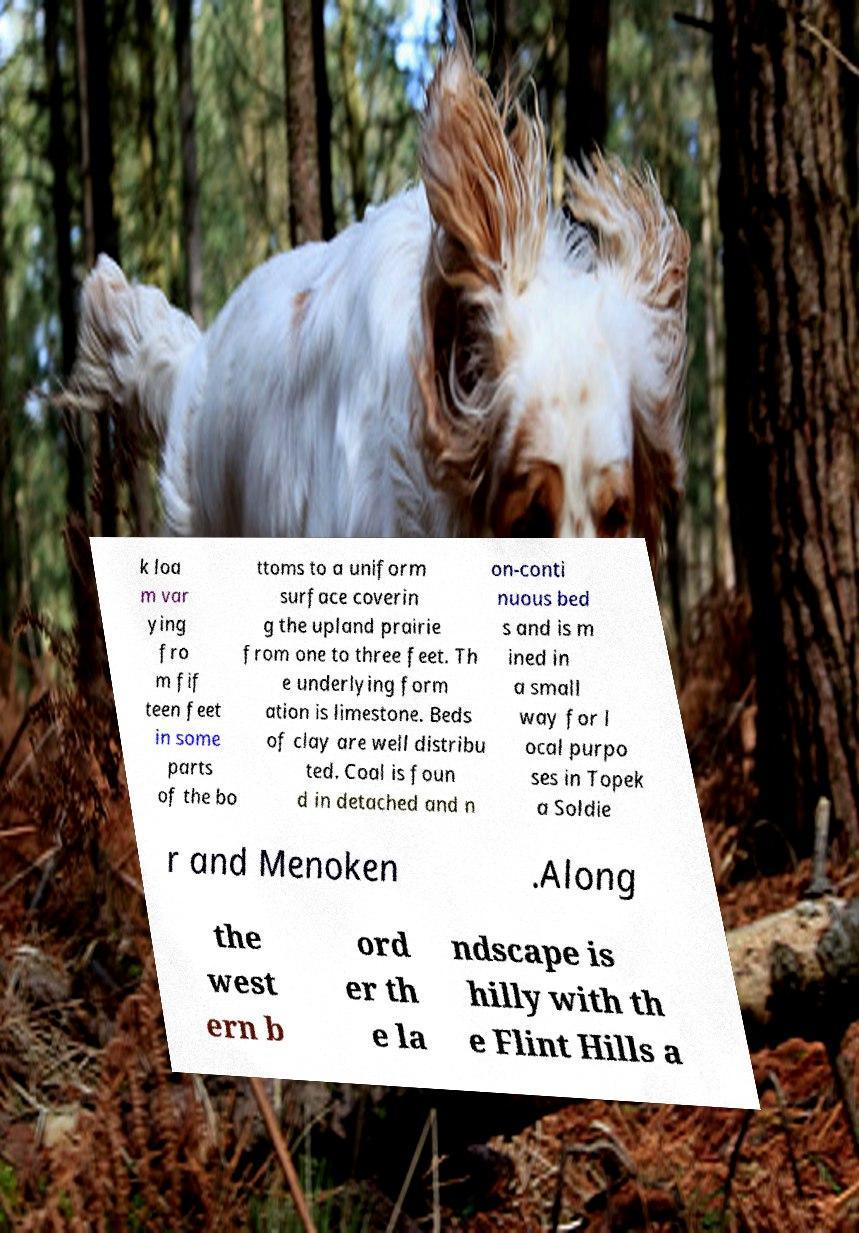There's text embedded in this image that I need extracted. Can you transcribe it verbatim? k loa m var ying fro m fif teen feet in some parts of the bo ttoms to a uniform surface coverin g the upland prairie from one to three feet. Th e underlying form ation is limestone. Beds of clay are well distribu ted. Coal is foun d in detached and n on-conti nuous bed s and is m ined in a small way for l ocal purpo ses in Topek a Soldie r and Menoken .Along the west ern b ord er th e la ndscape is hilly with th e Flint Hills a 